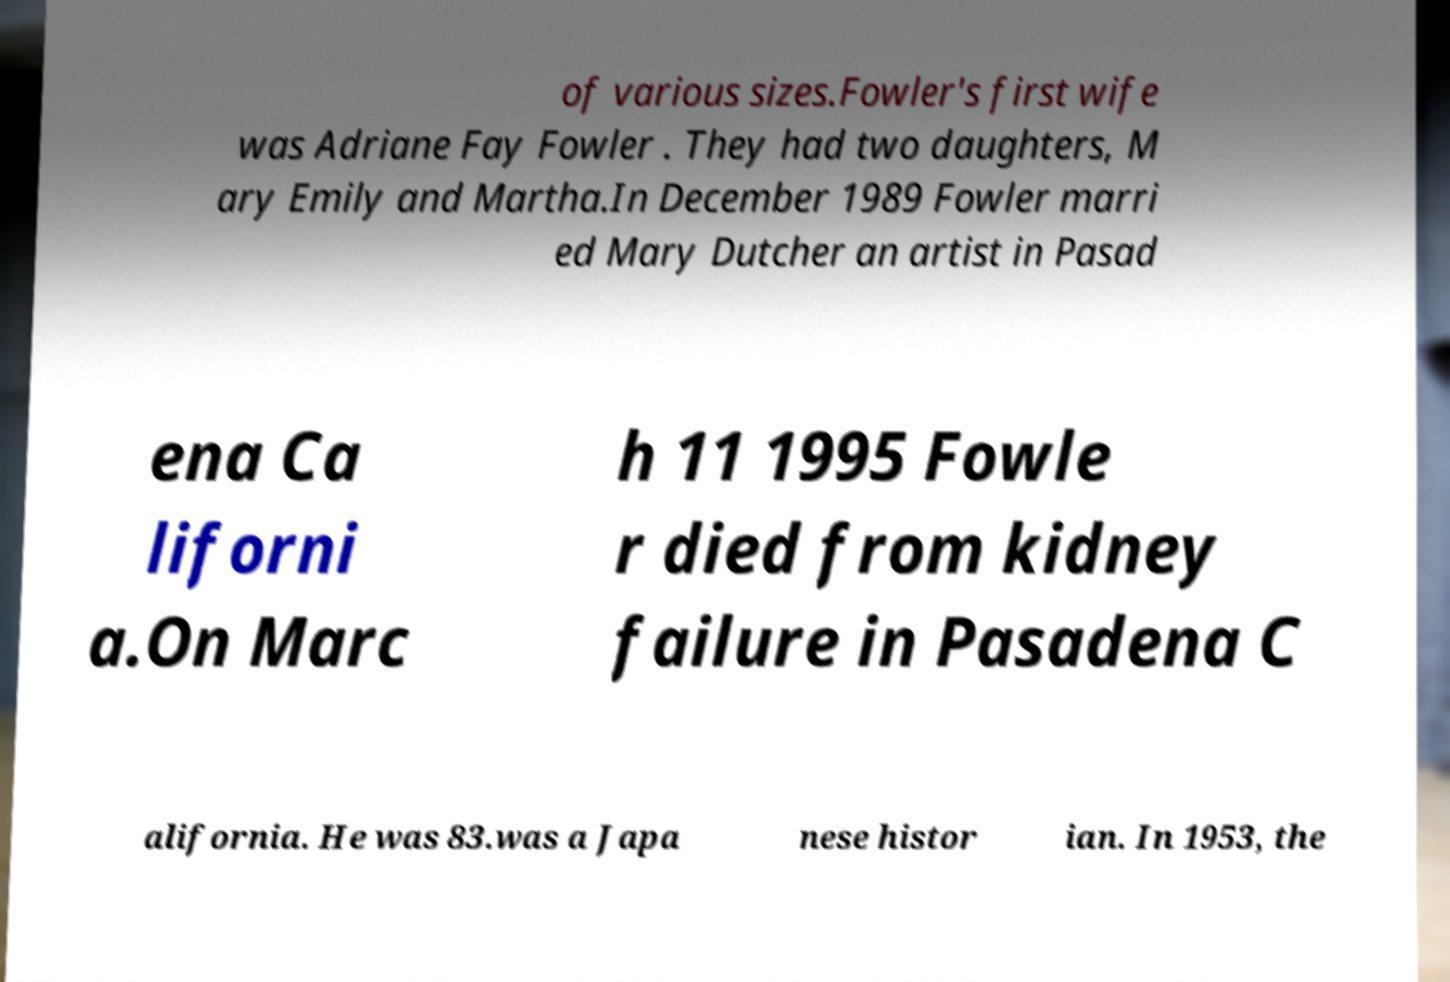Could you assist in decoding the text presented in this image and type it out clearly? of various sizes.Fowler's first wife was Adriane Fay Fowler . They had two daughters, M ary Emily and Martha.In December 1989 Fowler marri ed Mary Dutcher an artist in Pasad ena Ca liforni a.On Marc h 11 1995 Fowle r died from kidney failure in Pasadena C alifornia. He was 83.was a Japa nese histor ian. In 1953, the 